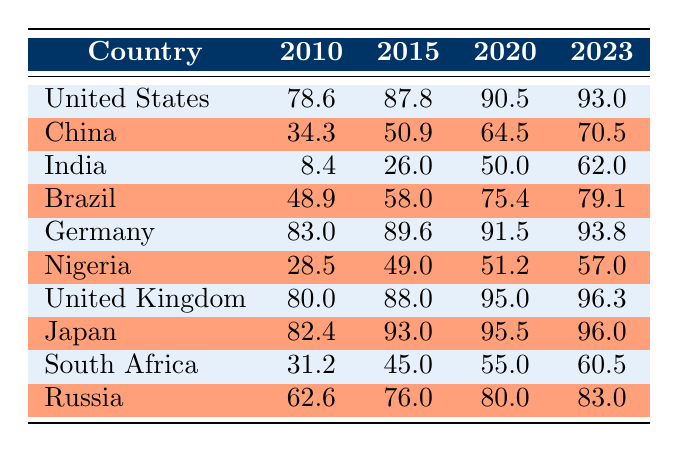What was the internet penetration rate in India in 2015? In the table under the row for India, I can find the value listed for the year 2015. It states that the internet penetration rate was 26.0.
Answer: 26.0 Which country had the highest internet penetration rate in 2020? Looking through the 2020 column, I check each country's value. The highest value is 95.5, which belongs to Japan.
Answer: Japan What is the difference in internet penetration rates for Nigeria between 2010 and 2023? To find the difference, I will look at the values in the columns for Nigeria in both 2010 (28.5) and 2023 (57.0). The difference is calculated as 57.0 - 28.5 = 28.5.
Answer: 28.5 Did the internet penetration rate in China increase from 2010 to 2023? I will check the values for China for both years. In 2010, the rate was 34.3 and in 2023 it was 70.5. Since 70.5 is greater than 34.3, the rate indeed increased.
Answer: Yes What is the average internet penetration rate across all countries in 2023? First, I need to sum the values for each country in 2023: 93.0 (US) + 70.5 (China) + 62.0 (India) + 79.1 (Brazil) + 93.8 (Germany) + 57.0 (Nigeria) + 96.3 (UK) + 96.0 (Japan) + 60.5 (South Africa) + 83.0 (Russia) = 792.2. There are 10 countries, so the average is 792.2 / 10 = 79.22.
Answer: 79.22 Which countries had a penetration rate of over 80% in 2023, and how many are there? Checking the 2023 column, I find that the countries with rates over 80% are: United States (93.0), Germany (93.8), United Kingdom (96.3), Japan (96.0), and Russia (83.0). There are a total of 5 countries.
Answer: 5 